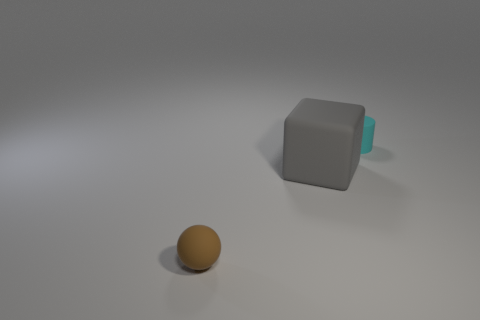Add 1 brown objects. How many objects exist? 4 Subtract all cylinders. How many objects are left? 2 Add 3 tiny spheres. How many tiny spheres are left? 4 Add 3 brown rubber things. How many brown rubber things exist? 4 Subtract 0 blue cylinders. How many objects are left? 3 Subtract all big cylinders. Subtract all cyan matte cylinders. How many objects are left? 2 